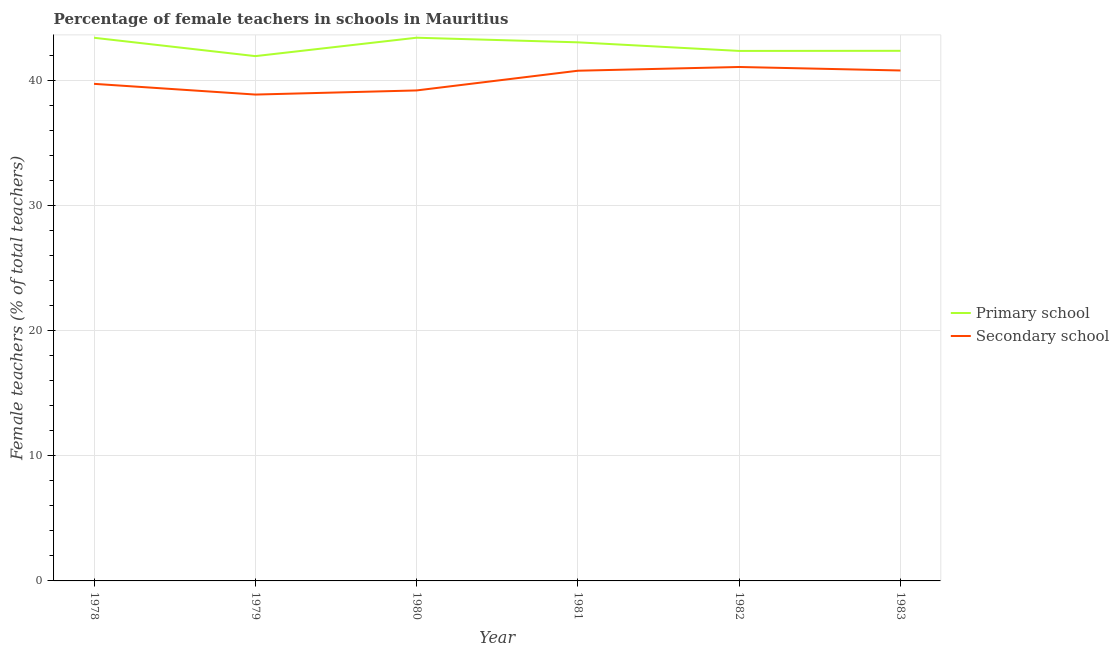What is the percentage of female teachers in primary schools in 1980?
Provide a succinct answer. 43.42. Across all years, what is the maximum percentage of female teachers in secondary schools?
Your answer should be compact. 41.08. Across all years, what is the minimum percentage of female teachers in primary schools?
Make the answer very short. 41.95. In which year was the percentage of female teachers in secondary schools maximum?
Provide a succinct answer. 1982. In which year was the percentage of female teachers in secondary schools minimum?
Give a very brief answer. 1979. What is the total percentage of female teachers in secondary schools in the graph?
Your response must be concise. 240.5. What is the difference between the percentage of female teachers in secondary schools in 1978 and that in 1982?
Provide a succinct answer. -1.35. What is the difference between the percentage of female teachers in secondary schools in 1979 and the percentage of female teachers in primary schools in 1980?
Your answer should be very brief. -4.54. What is the average percentage of female teachers in secondary schools per year?
Make the answer very short. 40.08. In the year 1981, what is the difference between the percentage of female teachers in secondary schools and percentage of female teachers in primary schools?
Offer a very short reply. -2.27. What is the ratio of the percentage of female teachers in secondary schools in 1978 to that in 1980?
Your answer should be very brief. 1.01. Is the percentage of female teachers in primary schools in 1979 less than that in 1980?
Your response must be concise. Yes. Is the difference between the percentage of female teachers in primary schools in 1980 and 1983 greater than the difference between the percentage of female teachers in secondary schools in 1980 and 1983?
Your answer should be compact. Yes. What is the difference between the highest and the second highest percentage of female teachers in primary schools?
Your answer should be very brief. 0. What is the difference between the highest and the lowest percentage of female teachers in primary schools?
Your answer should be compact. 1.47. In how many years, is the percentage of female teachers in primary schools greater than the average percentage of female teachers in primary schools taken over all years?
Keep it short and to the point. 3. Is the sum of the percentage of female teachers in primary schools in 1979 and 1981 greater than the maximum percentage of female teachers in secondary schools across all years?
Your answer should be very brief. Yes. Is the percentage of female teachers in secondary schools strictly greater than the percentage of female teachers in primary schools over the years?
Make the answer very short. No. How many lines are there?
Provide a short and direct response. 2. How many years are there in the graph?
Your response must be concise. 6. Does the graph contain grids?
Provide a succinct answer. Yes. How many legend labels are there?
Provide a succinct answer. 2. What is the title of the graph?
Give a very brief answer. Percentage of female teachers in schools in Mauritius. Does "National Tourists" appear as one of the legend labels in the graph?
Offer a very short reply. No. What is the label or title of the X-axis?
Your answer should be very brief. Year. What is the label or title of the Y-axis?
Your answer should be compact. Female teachers (% of total teachers). What is the Female teachers (% of total teachers) in Primary school in 1978?
Offer a very short reply. 43.42. What is the Female teachers (% of total teachers) in Secondary school in 1978?
Your answer should be very brief. 39.74. What is the Female teachers (% of total teachers) in Primary school in 1979?
Your answer should be very brief. 41.95. What is the Female teachers (% of total teachers) in Secondary school in 1979?
Your response must be concise. 38.88. What is the Female teachers (% of total teachers) of Primary school in 1980?
Offer a very short reply. 43.42. What is the Female teachers (% of total teachers) in Secondary school in 1980?
Give a very brief answer. 39.21. What is the Female teachers (% of total teachers) of Primary school in 1981?
Provide a succinct answer. 43.06. What is the Female teachers (% of total teachers) of Secondary school in 1981?
Provide a succinct answer. 40.79. What is the Female teachers (% of total teachers) in Primary school in 1982?
Offer a terse response. 42.37. What is the Female teachers (% of total teachers) in Secondary school in 1982?
Provide a succinct answer. 41.08. What is the Female teachers (% of total teachers) of Primary school in 1983?
Your response must be concise. 42.38. What is the Female teachers (% of total teachers) in Secondary school in 1983?
Your answer should be very brief. 40.8. Across all years, what is the maximum Female teachers (% of total teachers) of Primary school?
Your response must be concise. 43.42. Across all years, what is the maximum Female teachers (% of total teachers) of Secondary school?
Your answer should be compact. 41.08. Across all years, what is the minimum Female teachers (% of total teachers) of Primary school?
Your response must be concise. 41.95. Across all years, what is the minimum Female teachers (% of total teachers) in Secondary school?
Ensure brevity in your answer.  38.88. What is the total Female teachers (% of total teachers) in Primary school in the graph?
Ensure brevity in your answer.  256.59. What is the total Female teachers (% of total teachers) in Secondary school in the graph?
Offer a terse response. 240.5. What is the difference between the Female teachers (% of total teachers) in Primary school in 1978 and that in 1979?
Make the answer very short. 1.47. What is the difference between the Female teachers (% of total teachers) in Secondary school in 1978 and that in 1979?
Offer a very short reply. 0.86. What is the difference between the Female teachers (% of total teachers) of Primary school in 1978 and that in 1980?
Provide a succinct answer. -0. What is the difference between the Female teachers (% of total teachers) in Secondary school in 1978 and that in 1980?
Offer a terse response. 0.53. What is the difference between the Female teachers (% of total teachers) in Primary school in 1978 and that in 1981?
Your answer should be very brief. 0.36. What is the difference between the Female teachers (% of total teachers) in Secondary school in 1978 and that in 1981?
Your response must be concise. -1.05. What is the difference between the Female teachers (% of total teachers) in Primary school in 1978 and that in 1982?
Keep it short and to the point. 1.05. What is the difference between the Female teachers (% of total teachers) of Secondary school in 1978 and that in 1982?
Offer a terse response. -1.35. What is the difference between the Female teachers (% of total teachers) of Primary school in 1978 and that in 1983?
Give a very brief answer. 1.04. What is the difference between the Female teachers (% of total teachers) of Secondary school in 1978 and that in 1983?
Your answer should be very brief. -1.07. What is the difference between the Female teachers (% of total teachers) in Primary school in 1979 and that in 1980?
Your response must be concise. -1.47. What is the difference between the Female teachers (% of total teachers) in Secondary school in 1979 and that in 1980?
Your answer should be compact. -0.33. What is the difference between the Female teachers (% of total teachers) of Primary school in 1979 and that in 1981?
Ensure brevity in your answer.  -1.1. What is the difference between the Female teachers (% of total teachers) of Secondary school in 1979 and that in 1981?
Your response must be concise. -1.91. What is the difference between the Female teachers (% of total teachers) in Primary school in 1979 and that in 1982?
Offer a terse response. -0.42. What is the difference between the Female teachers (% of total teachers) of Secondary school in 1979 and that in 1982?
Make the answer very short. -2.2. What is the difference between the Female teachers (% of total teachers) of Primary school in 1979 and that in 1983?
Your answer should be very brief. -0.42. What is the difference between the Female teachers (% of total teachers) of Secondary school in 1979 and that in 1983?
Your response must be concise. -1.92. What is the difference between the Female teachers (% of total teachers) of Primary school in 1980 and that in 1981?
Provide a succinct answer. 0.37. What is the difference between the Female teachers (% of total teachers) of Secondary school in 1980 and that in 1981?
Keep it short and to the point. -1.58. What is the difference between the Female teachers (% of total teachers) of Primary school in 1980 and that in 1982?
Offer a very short reply. 1.06. What is the difference between the Female teachers (% of total teachers) of Secondary school in 1980 and that in 1982?
Ensure brevity in your answer.  -1.88. What is the difference between the Female teachers (% of total teachers) in Primary school in 1980 and that in 1983?
Ensure brevity in your answer.  1.05. What is the difference between the Female teachers (% of total teachers) in Secondary school in 1980 and that in 1983?
Your answer should be compact. -1.6. What is the difference between the Female teachers (% of total teachers) in Primary school in 1981 and that in 1982?
Make the answer very short. 0.69. What is the difference between the Female teachers (% of total teachers) in Secondary school in 1981 and that in 1982?
Your response must be concise. -0.3. What is the difference between the Female teachers (% of total teachers) in Primary school in 1981 and that in 1983?
Ensure brevity in your answer.  0.68. What is the difference between the Female teachers (% of total teachers) of Secondary school in 1981 and that in 1983?
Provide a succinct answer. -0.02. What is the difference between the Female teachers (% of total teachers) in Primary school in 1982 and that in 1983?
Your answer should be very brief. -0.01. What is the difference between the Female teachers (% of total teachers) of Secondary school in 1982 and that in 1983?
Your answer should be compact. 0.28. What is the difference between the Female teachers (% of total teachers) in Primary school in 1978 and the Female teachers (% of total teachers) in Secondary school in 1979?
Offer a very short reply. 4.54. What is the difference between the Female teachers (% of total teachers) of Primary school in 1978 and the Female teachers (% of total teachers) of Secondary school in 1980?
Make the answer very short. 4.21. What is the difference between the Female teachers (% of total teachers) of Primary school in 1978 and the Female teachers (% of total teachers) of Secondary school in 1981?
Provide a succinct answer. 2.63. What is the difference between the Female teachers (% of total teachers) in Primary school in 1978 and the Female teachers (% of total teachers) in Secondary school in 1982?
Ensure brevity in your answer.  2.33. What is the difference between the Female teachers (% of total teachers) of Primary school in 1978 and the Female teachers (% of total teachers) of Secondary school in 1983?
Offer a terse response. 2.61. What is the difference between the Female teachers (% of total teachers) of Primary school in 1979 and the Female teachers (% of total teachers) of Secondary school in 1980?
Provide a succinct answer. 2.74. What is the difference between the Female teachers (% of total teachers) in Primary school in 1979 and the Female teachers (% of total teachers) in Secondary school in 1981?
Make the answer very short. 1.17. What is the difference between the Female teachers (% of total teachers) in Primary school in 1979 and the Female teachers (% of total teachers) in Secondary school in 1982?
Keep it short and to the point. 0.87. What is the difference between the Female teachers (% of total teachers) in Primary school in 1979 and the Female teachers (% of total teachers) in Secondary school in 1983?
Your answer should be very brief. 1.15. What is the difference between the Female teachers (% of total teachers) in Primary school in 1980 and the Female teachers (% of total teachers) in Secondary school in 1981?
Your answer should be very brief. 2.64. What is the difference between the Female teachers (% of total teachers) of Primary school in 1980 and the Female teachers (% of total teachers) of Secondary school in 1982?
Provide a succinct answer. 2.34. What is the difference between the Female teachers (% of total teachers) of Primary school in 1980 and the Female teachers (% of total teachers) of Secondary school in 1983?
Ensure brevity in your answer.  2.62. What is the difference between the Female teachers (% of total teachers) of Primary school in 1981 and the Female teachers (% of total teachers) of Secondary school in 1982?
Provide a short and direct response. 1.97. What is the difference between the Female teachers (% of total teachers) of Primary school in 1981 and the Female teachers (% of total teachers) of Secondary school in 1983?
Offer a terse response. 2.25. What is the difference between the Female teachers (% of total teachers) of Primary school in 1982 and the Female teachers (% of total teachers) of Secondary school in 1983?
Your answer should be compact. 1.56. What is the average Female teachers (% of total teachers) of Primary school per year?
Your answer should be very brief. 42.77. What is the average Female teachers (% of total teachers) in Secondary school per year?
Your response must be concise. 40.08. In the year 1978, what is the difference between the Female teachers (% of total teachers) in Primary school and Female teachers (% of total teachers) in Secondary school?
Keep it short and to the point. 3.68. In the year 1979, what is the difference between the Female teachers (% of total teachers) of Primary school and Female teachers (% of total teachers) of Secondary school?
Offer a very short reply. 3.07. In the year 1980, what is the difference between the Female teachers (% of total teachers) in Primary school and Female teachers (% of total teachers) in Secondary school?
Your answer should be compact. 4.21. In the year 1981, what is the difference between the Female teachers (% of total teachers) of Primary school and Female teachers (% of total teachers) of Secondary school?
Keep it short and to the point. 2.27. In the year 1982, what is the difference between the Female teachers (% of total teachers) of Primary school and Female teachers (% of total teachers) of Secondary school?
Your response must be concise. 1.28. In the year 1983, what is the difference between the Female teachers (% of total teachers) in Primary school and Female teachers (% of total teachers) in Secondary school?
Your answer should be very brief. 1.57. What is the ratio of the Female teachers (% of total teachers) of Primary school in 1978 to that in 1979?
Your response must be concise. 1.03. What is the ratio of the Female teachers (% of total teachers) of Secondary school in 1978 to that in 1979?
Provide a succinct answer. 1.02. What is the ratio of the Female teachers (% of total teachers) of Secondary school in 1978 to that in 1980?
Your answer should be very brief. 1.01. What is the ratio of the Female teachers (% of total teachers) in Primary school in 1978 to that in 1981?
Your response must be concise. 1.01. What is the ratio of the Female teachers (% of total teachers) in Secondary school in 1978 to that in 1981?
Your response must be concise. 0.97. What is the ratio of the Female teachers (% of total teachers) of Primary school in 1978 to that in 1982?
Provide a succinct answer. 1.02. What is the ratio of the Female teachers (% of total teachers) of Secondary school in 1978 to that in 1982?
Your response must be concise. 0.97. What is the ratio of the Female teachers (% of total teachers) of Primary school in 1978 to that in 1983?
Provide a short and direct response. 1.02. What is the ratio of the Female teachers (% of total teachers) in Secondary school in 1978 to that in 1983?
Offer a terse response. 0.97. What is the ratio of the Female teachers (% of total teachers) of Primary school in 1979 to that in 1980?
Offer a very short reply. 0.97. What is the ratio of the Female teachers (% of total teachers) of Primary school in 1979 to that in 1981?
Your answer should be very brief. 0.97. What is the ratio of the Female teachers (% of total teachers) of Secondary school in 1979 to that in 1981?
Offer a very short reply. 0.95. What is the ratio of the Female teachers (% of total teachers) of Primary school in 1979 to that in 1982?
Your answer should be very brief. 0.99. What is the ratio of the Female teachers (% of total teachers) of Secondary school in 1979 to that in 1982?
Offer a terse response. 0.95. What is the ratio of the Female teachers (% of total teachers) of Secondary school in 1979 to that in 1983?
Your answer should be compact. 0.95. What is the ratio of the Female teachers (% of total teachers) of Primary school in 1980 to that in 1981?
Keep it short and to the point. 1.01. What is the ratio of the Female teachers (% of total teachers) of Secondary school in 1980 to that in 1981?
Your answer should be compact. 0.96. What is the ratio of the Female teachers (% of total teachers) in Primary school in 1980 to that in 1982?
Offer a terse response. 1.02. What is the ratio of the Female teachers (% of total teachers) in Secondary school in 1980 to that in 1982?
Your answer should be very brief. 0.95. What is the ratio of the Female teachers (% of total teachers) in Primary school in 1980 to that in 1983?
Offer a terse response. 1.02. What is the ratio of the Female teachers (% of total teachers) in Secondary school in 1980 to that in 1983?
Provide a succinct answer. 0.96. What is the ratio of the Female teachers (% of total teachers) in Primary school in 1981 to that in 1982?
Give a very brief answer. 1.02. What is the ratio of the Female teachers (% of total teachers) of Secondary school in 1981 to that in 1982?
Offer a terse response. 0.99. What is the ratio of the Female teachers (% of total teachers) in Primary school in 1981 to that in 1983?
Make the answer very short. 1.02. What is the ratio of the Female teachers (% of total teachers) of Secondary school in 1981 to that in 1983?
Provide a short and direct response. 1. What is the difference between the highest and the second highest Female teachers (% of total teachers) in Primary school?
Offer a terse response. 0. What is the difference between the highest and the second highest Female teachers (% of total teachers) of Secondary school?
Ensure brevity in your answer.  0.28. What is the difference between the highest and the lowest Female teachers (% of total teachers) of Primary school?
Give a very brief answer. 1.47. What is the difference between the highest and the lowest Female teachers (% of total teachers) in Secondary school?
Ensure brevity in your answer.  2.2. 